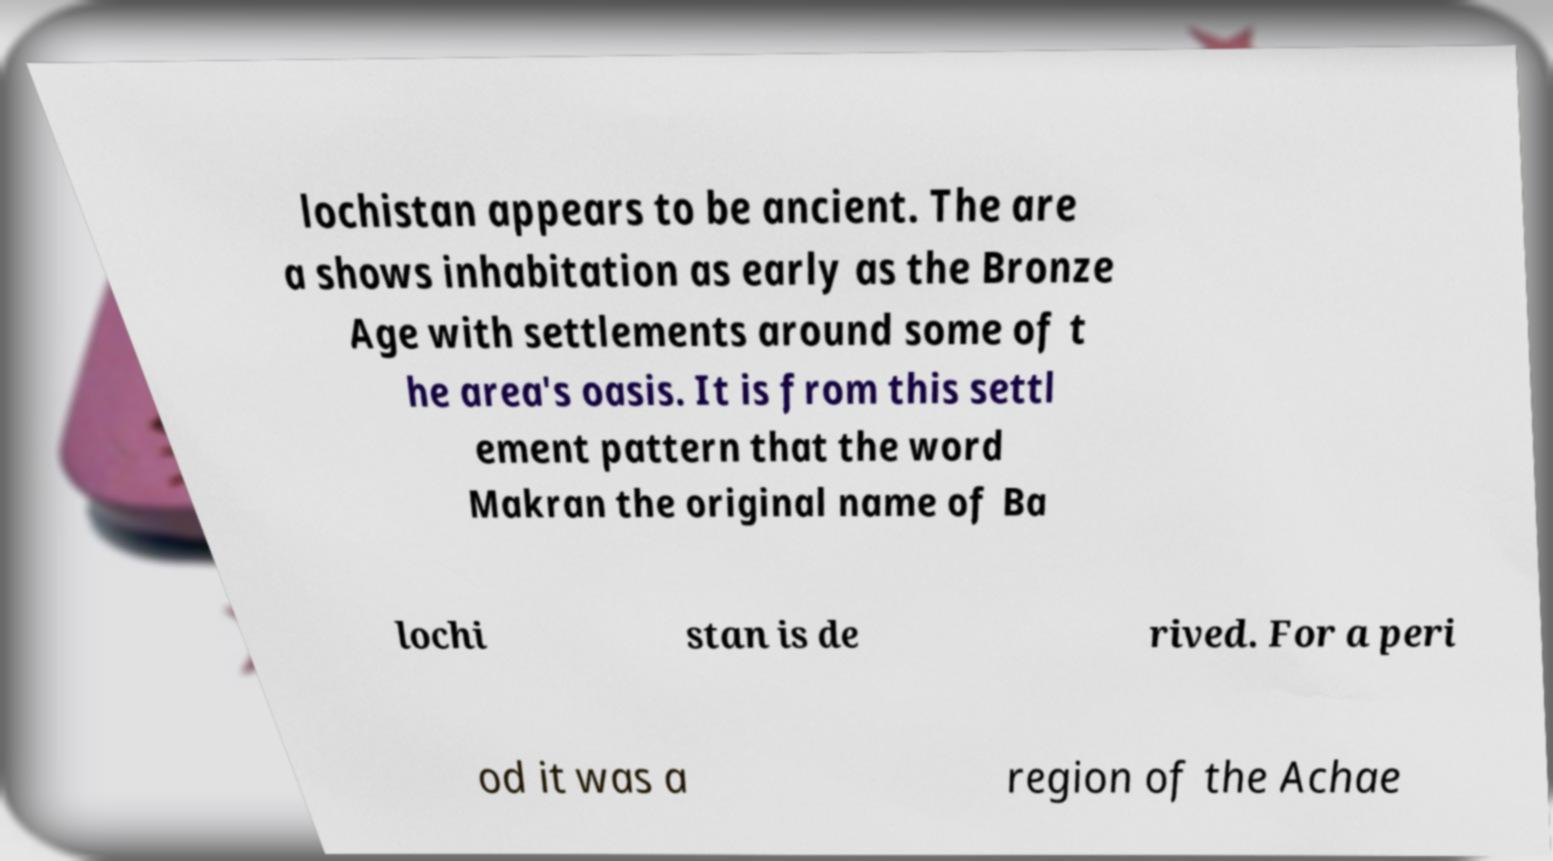Could you extract and type out the text from this image? lochistan appears to be ancient. The are a shows inhabitation as early as the Bronze Age with settlements around some of t he area's oasis. It is from this settl ement pattern that the word Makran the original name of Ba lochi stan is de rived. For a peri od it was a region of the Achae 